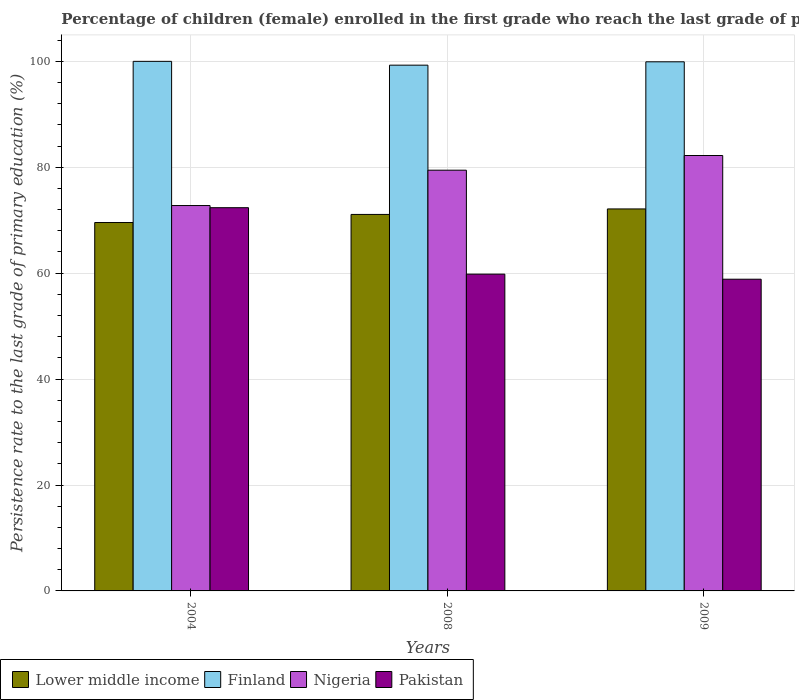How many different coloured bars are there?
Your answer should be very brief. 4. How many bars are there on the 3rd tick from the left?
Ensure brevity in your answer.  4. What is the label of the 3rd group of bars from the left?
Your response must be concise. 2009. What is the persistence rate of children in Pakistan in 2009?
Offer a very short reply. 58.86. Across all years, what is the maximum persistence rate of children in Nigeria?
Your answer should be very brief. 82.22. Across all years, what is the minimum persistence rate of children in Lower middle income?
Provide a succinct answer. 69.56. In which year was the persistence rate of children in Lower middle income maximum?
Your response must be concise. 2009. What is the total persistence rate of children in Finland in the graph?
Ensure brevity in your answer.  299.19. What is the difference between the persistence rate of children in Nigeria in 2008 and that in 2009?
Your answer should be compact. -2.77. What is the difference between the persistence rate of children in Nigeria in 2008 and the persistence rate of children in Finland in 2009?
Ensure brevity in your answer.  -20.47. What is the average persistence rate of children in Nigeria per year?
Provide a short and direct response. 78.15. In the year 2008, what is the difference between the persistence rate of children in Finland and persistence rate of children in Lower middle income?
Make the answer very short. 28.19. What is the ratio of the persistence rate of children in Finland in 2008 to that in 2009?
Your answer should be compact. 0.99. Is the difference between the persistence rate of children in Finland in 2004 and 2008 greater than the difference between the persistence rate of children in Lower middle income in 2004 and 2008?
Keep it short and to the point. Yes. What is the difference between the highest and the second highest persistence rate of children in Finland?
Make the answer very short. 0.09. What is the difference between the highest and the lowest persistence rate of children in Pakistan?
Offer a terse response. 13.5. In how many years, is the persistence rate of children in Nigeria greater than the average persistence rate of children in Nigeria taken over all years?
Your response must be concise. 2. What does the 2nd bar from the left in 2009 represents?
Keep it short and to the point. Finland. Is it the case that in every year, the sum of the persistence rate of children in Pakistan and persistence rate of children in Lower middle income is greater than the persistence rate of children in Nigeria?
Ensure brevity in your answer.  Yes. How many bars are there?
Your response must be concise. 12. What is the difference between two consecutive major ticks on the Y-axis?
Keep it short and to the point. 20. Are the values on the major ticks of Y-axis written in scientific E-notation?
Your answer should be very brief. No. Does the graph contain any zero values?
Give a very brief answer. No. How are the legend labels stacked?
Your response must be concise. Horizontal. What is the title of the graph?
Give a very brief answer. Percentage of children (female) enrolled in the first grade who reach the last grade of primary education. What is the label or title of the Y-axis?
Ensure brevity in your answer.  Persistence rate to the last grade of primary education (%). What is the Persistence rate to the last grade of primary education (%) of Lower middle income in 2004?
Your response must be concise. 69.56. What is the Persistence rate to the last grade of primary education (%) of Finland in 2004?
Offer a terse response. 100. What is the Persistence rate to the last grade of primary education (%) of Nigeria in 2004?
Give a very brief answer. 72.77. What is the Persistence rate to the last grade of primary education (%) of Pakistan in 2004?
Provide a short and direct response. 72.36. What is the Persistence rate to the last grade of primary education (%) of Lower middle income in 2008?
Offer a terse response. 71.09. What is the Persistence rate to the last grade of primary education (%) in Finland in 2008?
Keep it short and to the point. 99.28. What is the Persistence rate to the last grade of primary education (%) of Nigeria in 2008?
Provide a succinct answer. 79.44. What is the Persistence rate to the last grade of primary education (%) of Pakistan in 2008?
Make the answer very short. 59.82. What is the Persistence rate to the last grade of primary education (%) in Lower middle income in 2009?
Provide a succinct answer. 72.13. What is the Persistence rate to the last grade of primary education (%) of Finland in 2009?
Offer a terse response. 99.91. What is the Persistence rate to the last grade of primary education (%) of Nigeria in 2009?
Give a very brief answer. 82.22. What is the Persistence rate to the last grade of primary education (%) in Pakistan in 2009?
Provide a short and direct response. 58.86. Across all years, what is the maximum Persistence rate to the last grade of primary education (%) of Lower middle income?
Make the answer very short. 72.13. Across all years, what is the maximum Persistence rate to the last grade of primary education (%) of Finland?
Provide a short and direct response. 100. Across all years, what is the maximum Persistence rate to the last grade of primary education (%) of Nigeria?
Offer a very short reply. 82.22. Across all years, what is the maximum Persistence rate to the last grade of primary education (%) in Pakistan?
Keep it short and to the point. 72.36. Across all years, what is the minimum Persistence rate to the last grade of primary education (%) in Lower middle income?
Provide a short and direct response. 69.56. Across all years, what is the minimum Persistence rate to the last grade of primary education (%) in Finland?
Give a very brief answer. 99.28. Across all years, what is the minimum Persistence rate to the last grade of primary education (%) of Nigeria?
Your answer should be very brief. 72.77. Across all years, what is the minimum Persistence rate to the last grade of primary education (%) of Pakistan?
Provide a short and direct response. 58.86. What is the total Persistence rate to the last grade of primary education (%) in Lower middle income in the graph?
Offer a terse response. 212.79. What is the total Persistence rate to the last grade of primary education (%) of Finland in the graph?
Offer a terse response. 299.19. What is the total Persistence rate to the last grade of primary education (%) in Nigeria in the graph?
Make the answer very short. 234.44. What is the total Persistence rate to the last grade of primary education (%) of Pakistan in the graph?
Your response must be concise. 191.04. What is the difference between the Persistence rate to the last grade of primary education (%) of Lower middle income in 2004 and that in 2008?
Give a very brief answer. -1.53. What is the difference between the Persistence rate to the last grade of primary education (%) of Finland in 2004 and that in 2008?
Give a very brief answer. 0.72. What is the difference between the Persistence rate to the last grade of primary education (%) in Nigeria in 2004 and that in 2008?
Give a very brief answer. -6.67. What is the difference between the Persistence rate to the last grade of primary education (%) in Pakistan in 2004 and that in 2008?
Offer a very short reply. 12.54. What is the difference between the Persistence rate to the last grade of primary education (%) in Lower middle income in 2004 and that in 2009?
Your answer should be very brief. -2.57. What is the difference between the Persistence rate to the last grade of primary education (%) in Finland in 2004 and that in 2009?
Provide a short and direct response. 0.09. What is the difference between the Persistence rate to the last grade of primary education (%) of Nigeria in 2004 and that in 2009?
Keep it short and to the point. -9.45. What is the difference between the Persistence rate to the last grade of primary education (%) of Pakistan in 2004 and that in 2009?
Give a very brief answer. 13.5. What is the difference between the Persistence rate to the last grade of primary education (%) of Lower middle income in 2008 and that in 2009?
Give a very brief answer. -1.04. What is the difference between the Persistence rate to the last grade of primary education (%) of Finland in 2008 and that in 2009?
Keep it short and to the point. -0.63. What is the difference between the Persistence rate to the last grade of primary education (%) in Nigeria in 2008 and that in 2009?
Provide a succinct answer. -2.77. What is the difference between the Persistence rate to the last grade of primary education (%) in Pakistan in 2008 and that in 2009?
Ensure brevity in your answer.  0.96. What is the difference between the Persistence rate to the last grade of primary education (%) of Lower middle income in 2004 and the Persistence rate to the last grade of primary education (%) of Finland in 2008?
Your answer should be very brief. -29.71. What is the difference between the Persistence rate to the last grade of primary education (%) in Lower middle income in 2004 and the Persistence rate to the last grade of primary education (%) in Nigeria in 2008?
Keep it short and to the point. -9.88. What is the difference between the Persistence rate to the last grade of primary education (%) in Lower middle income in 2004 and the Persistence rate to the last grade of primary education (%) in Pakistan in 2008?
Provide a short and direct response. 9.74. What is the difference between the Persistence rate to the last grade of primary education (%) in Finland in 2004 and the Persistence rate to the last grade of primary education (%) in Nigeria in 2008?
Provide a succinct answer. 20.55. What is the difference between the Persistence rate to the last grade of primary education (%) of Finland in 2004 and the Persistence rate to the last grade of primary education (%) of Pakistan in 2008?
Ensure brevity in your answer.  40.18. What is the difference between the Persistence rate to the last grade of primary education (%) in Nigeria in 2004 and the Persistence rate to the last grade of primary education (%) in Pakistan in 2008?
Ensure brevity in your answer.  12.95. What is the difference between the Persistence rate to the last grade of primary education (%) in Lower middle income in 2004 and the Persistence rate to the last grade of primary education (%) in Finland in 2009?
Offer a very short reply. -30.35. What is the difference between the Persistence rate to the last grade of primary education (%) of Lower middle income in 2004 and the Persistence rate to the last grade of primary education (%) of Nigeria in 2009?
Make the answer very short. -12.66. What is the difference between the Persistence rate to the last grade of primary education (%) in Lower middle income in 2004 and the Persistence rate to the last grade of primary education (%) in Pakistan in 2009?
Provide a short and direct response. 10.7. What is the difference between the Persistence rate to the last grade of primary education (%) of Finland in 2004 and the Persistence rate to the last grade of primary education (%) of Nigeria in 2009?
Your answer should be very brief. 17.78. What is the difference between the Persistence rate to the last grade of primary education (%) of Finland in 2004 and the Persistence rate to the last grade of primary education (%) of Pakistan in 2009?
Your answer should be very brief. 41.14. What is the difference between the Persistence rate to the last grade of primary education (%) in Nigeria in 2004 and the Persistence rate to the last grade of primary education (%) in Pakistan in 2009?
Offer a very short reply. 13.91. What is the difference between the Persistence rate to the last grade of primary education (%) in Lower middle income in 2008 and the Persistence rate to the last grade of primary education (%) in Finland in 2009?
Your answer should be very brief. -28.82. What is the difference between the Persistence rate to the last grade of primary education (%) of Lower middle income in 2008 and the Persistence rate to the last grade of primary education (%) of Nigeria in 2009?
Make the answer very short. -11.13. What is the difference between the Persistence rate to the last grade of primary education (%) in Lower middle income in 2008 and the Persistence rate to the last grade of primary education (%) in Pakistan in 2009?
Your answer should be compact. 12.23. What is the difference between the Persistence rate to the last grade of primary education (%) of Finland in 2008 and the Persistence rate to the last grade of primary education (%) of Nigeria in 2009?
Offer a very short reply. 17.06. What is the difference between the Persistence rate to the last grade of primary education (%) in Finland in 2008 and the Persistence rate to the last grade of primary education (%) in Pakistan in 2009?
Offer a terse response. 40.42. What is the difference between the Persistence rate to the last grade of primary education (%) in Nigeria in 2008 and the Persistence rate to the last grade of primary education (%) in Pakistan in 2009?
Ensure brevity in your answer.  20.58. What is the average Persistence rate to the last grade of primary education (%) in Lower middle income per year?
Your response must be concise. 70.93. What is the average Persistence rate to the last grade of primary education (%) of Finland per year?
Give a very brief answer. 99.73. What is the average Persistence rate to the last grade of primary education (%) of Nigeria per year?
Your answer should be very brief. 78.15. What is the average Persistence rate to the last grade of primary education (%) of Pakistan per year?
Your answer should be very brief. 63.68. In the year 2004, what is the difference between the Persistence rate to the last grade of primary education (%) in Lower middle income and Persistence rate to the last grade of primary education (%) in Finland?
Your response must be concise. -30.43. In the year 2004, what is the difference between the Persistence rate to the last grade of primary education (%) of Lower middle income and Persistence rate to the last grade of primary education (%) of Nigeria?
Provide a short and direct response. -3.21. In the year 2004, what is the difference between the Persistence rate to the last grade of primary education (%) of Lower middle income and Persistence rate to the last grade of primary education (%) of Pakistan?
Your answer should be compact. -2.8. In the year 2004, what is the difference between the Persistence rate to the last grade of primary education (%) of Finland and Persistence rate to the last grade of primary education (%) of Nigeria?
Provide a short and direct response. 27.23. In the year 2004, what is the difference between the Persistence rate to the last grade of primary education (%) of Finland and Persistence rate to the last grade of primary education (%) of Pakistan?
Your response must be concise. 27.63. In the year 2004, what is the difference between the Persistence rate to the last grade of primary education (%) of Nigeria and Persistence rate to the last grade of primary education (%) of Pakistan?
Give a very brief answer. 0.41. In the year 2008, what is the difference between the Persistence rate to the last grade of primary education (%) of Lower middle income and Persistence rate to the last grade of primary education (%) of Finland?
Provide a succinct answer. -28.19. In the year 2008, what is the difference between the Persistence rate to the last grade of primary education (%) in Lower middle income and Persistence rate to the last grade of primary education (%) in Nigeria?
Give a very brief answer. -8.35. In the year 2008, what is the difference between the Persistence rate to the last grade of primary education (%) of Lower middle income and Persistence rate to the last grade of primary education (%) of Pakistan?
Provide a succinct answer. 11.27. In the year 2008, what is the difference between the Persistence rate to the last grade of primary education (%) of Finland and Persistence rate to the last grade of primary education (%) of Nigeria?
Give a very brief answer. 19.83. In the year 2008, what is the difference between the Persistence rate to the last grade of primary education (%) in Finland and Persistence rate to the last grade of primary education (%) in Pakistan?
Give a very brief answer. 39.46. In the year 2008, what is the difference between the Persistence rate to the last grade of primary education (%) in Nigeria and Persistence rate to the last grade of primary education (%) in Pakistan?
Your answer should be compact. 19.63. In the year 2009, what is the difference between the Persistence rate to the last grade of primary education (%) of Lower middle income and Persistence rate to the last grade of primary education (%) of Finland?
Offer a terse response. -27.78. In the year 2009, what is the difference between the Persistence rate to the last grade of primary education (%) in Lower middle income and Persistence rate to the last grade of primary education (%) in Nigeria?
Your answer should be compact. -10.09. In the year 2009, what is the difference between the Persistence rate to the last grade of primary education (%) in Lower middle income and Persistence rate to the last grade of primary education (%) in Pakistan?
Provide a short and direct response. 13.27. In the year 2009, what is the difference between the Persistence rate to the last grade of primary education (%) of Finland and Persistence rate to the last grade of primary education (%) of Nigeria?
Your answer should be very brief. 17.69. In the year 2009, what is the difference between the Persistence rate to the last grade of primary education (%) of Finland and Persistence rate to the last grade of primary education (%) of Pakistan?
Keep it short and to the point. 41.05. In the year 2009, what is the difference between the Persistence rate to the last grade of primary education (%) in Nigeria and Persistence rate to the last grade of primary education (%) in Pakistan?
Your answer should be very brief. 23.36. What is the ratio of the Persistence rate to the last grade of primary education (%) of Lower middle income in 2004 to that in 2008?
Give a very brief answer. 0.98. What is the ratio of the Persistence rate to the last grade of primary education (%) of Finland in 2004 to that in 2008?
Keep it short and to the point. 1.01. What is the ratio of the Persistence rate to the last grade of primary education (%) in Nigeria in 2004 to that in 2008?
Ensure brevity in your answer.  0.92. What is the ratio of the Persistence rate to the last grade of primary education (%) in Pakistan in 2004 to that in 2008?
Offer a terse response. 1.21. What is the ratio of the Persistence rate to the last grade of primary education (%) of Lower middle income in 2004 to that in 2009?
Provide a succinct answer. 0.96. What is the ratio of the Persistence rate to the last grade of primary education (%) of Finland in 2004 to that in 2009?
Offer a terse response. 1. What is the ratio of the Persistence rate to the last grade of primary education (%) of Nigeria in 2004 to that in 2009?
Offer a terse response. 0.89. What is the ratio of the Persistence rate to the last grade of primary education (%) of Pakistan in 2004 to that in 2009?
Give a very brief answer. 1.23. What is the ratio of the Persistence rate to the last grade of primary education (%) in Lower middle income in 2008 to that in 2009?
Your answer should be very brief. 0.99. What is the ratio of the Persistence rate to the last grade of primary education (%) in Nigeria in 2008 to that in 2009?
Keep it short and to the point. 0.97. What is the ratio of the Persistence rate to the last grade of primary education (%) of Pakistan in 2008 to that in 2009?
Offer a very short reply. 1.02. What is the difference between the highest and the second highest Persistence rate to the last grade of primary education (%) of Lower middle income?
Make the answer very short. 1.04. What is the difference between the highest and the second highest Persistence rate to the last grade of primary education (%) in Finland?
Ensure brevity in your answer.  0.09. What is the difference between the highest and the second highest Persistence rate to the last grade of primary education (%) of Nigeria?
Offer a very short reply. 2.77. What is the difference between the highest and the second highest Persistence rate to the last grade of primary education (%) of Pakistan?
Your answer should be very brief. 12.54. What is the difference between the highest and the lowest Persistence rate to the last grade of primary education (%) in Lower middle income?
Provide a succinct answer. 2.57. What is the difference between the highest and the lowest Persistence rate to the last grade of primary education (%) of Finland?
Your answer should be compact. 0.72. What is the difference between the highest and the lowest Persistence rate to the last grade of primary education (%) of Nigeria?
Your answer should be compact. 9.45. What is the difference between the highest and the lowest Persistence rate to the last grade of primary education (%) in Pakistan?
Make the answer very short. 13.5. 